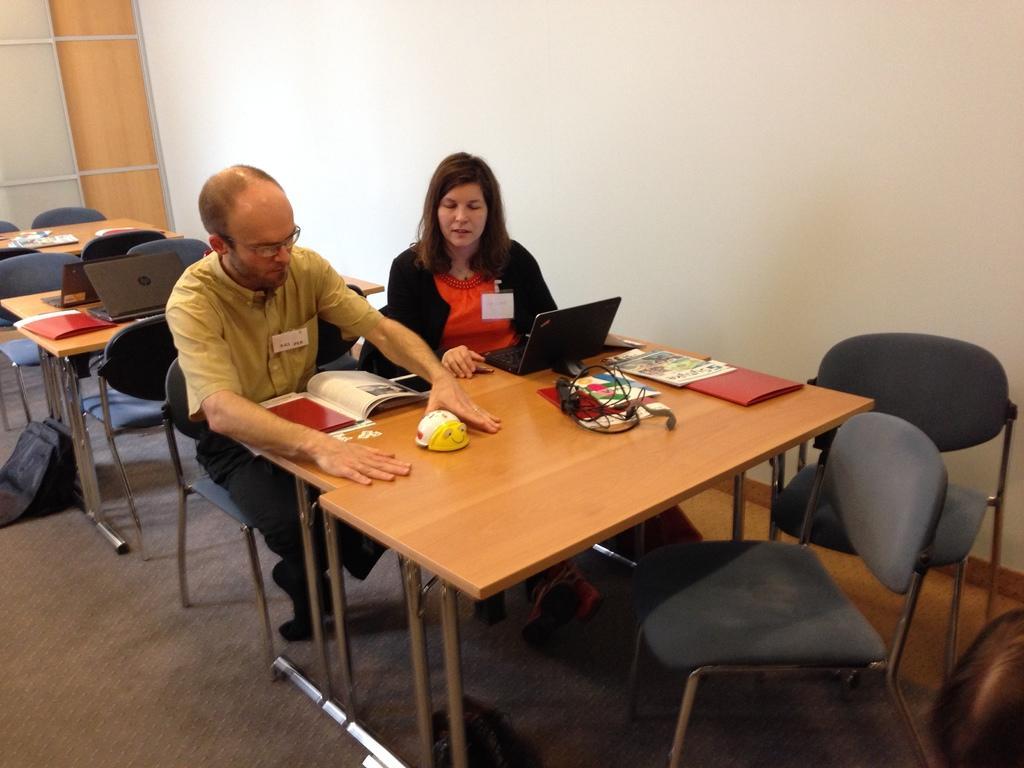How would you summarize this image in a sentence or two? This picture is clicked inside the room. In the middle of the picture, we see woman wearing black jacket and red t-shirt is sitting on a chair. Beside her, we see man in yellow shirt and black pant is putting his hands on the table. In front of them, we see a table on which headset, file, book, papers are placed. We can see many chairs and tables in this picture and on the left corner, we see a bag which is black in color. Beside them, we see white wall. 